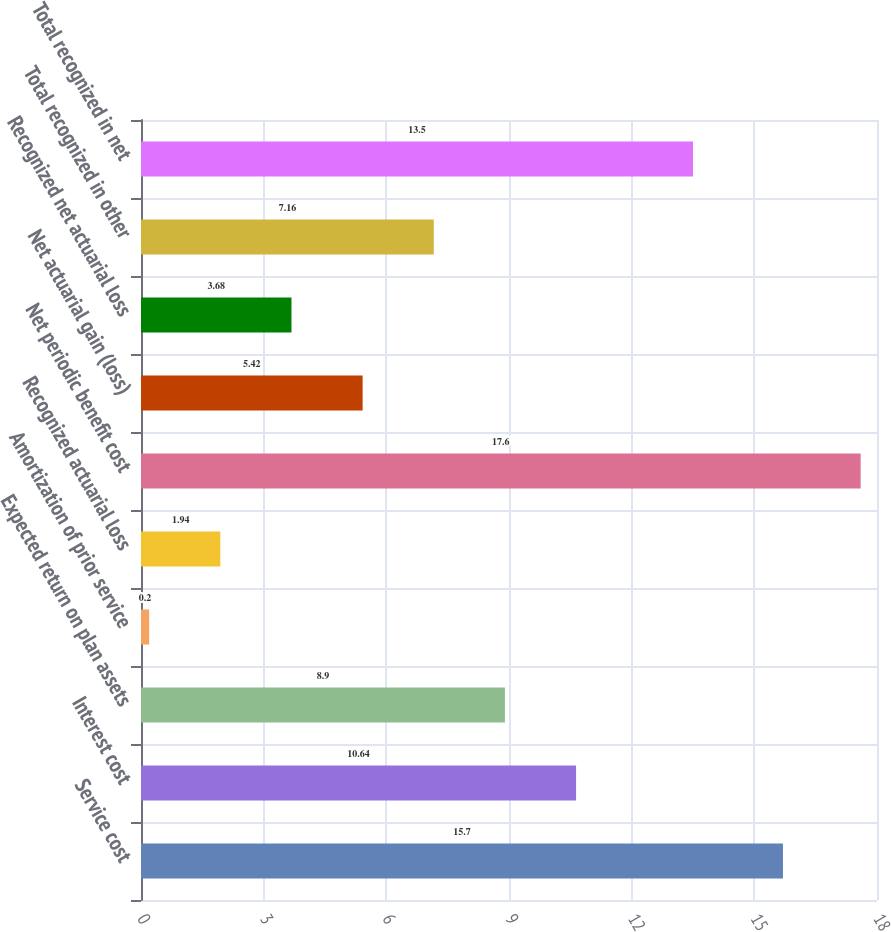Convert chart to OTSL. <chart><loc_0><loc_0><loc_500><loc_500><bar_chart><fcel>Service cost<fcel>Interest cost<fcel>Expected return on plan assets<fcel>Amortization of prior service<fcel>Recognized actuarial loss<fcel>Net periodic benefit cost<fcel>Net actuarial gain (loss)<fcel>Recognized net actuarial loss<fcel>Total recognized in other<fcel>Total recognized in net<nl><fcel>15.7<fcel>10.64<fcel>8.9<fcel>0.2<fcel>1.94<fcel>17.6<fcel>5.42<fcel>3.68<fcel>7.16<fcel>13.5<nl></chart> 